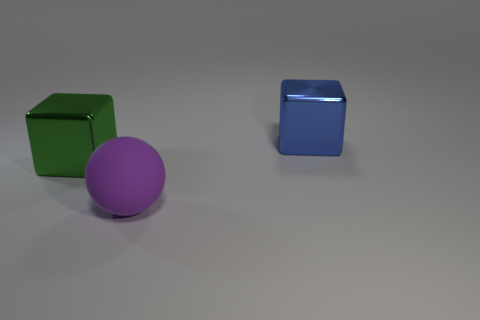Add 3 purple matte balls. How many objects exist? 6 Subtract all spheres. How many objects are left? 2 Subtract all brown things. Subtract all big spheres. How many objects are left? 2 Add 2 purple matte things. How many purple matte things are left? 3 Add 2 purple spheres. How many purple spheres exist? 3 Subtract 0 red cylinders. How many objects are left? 3 